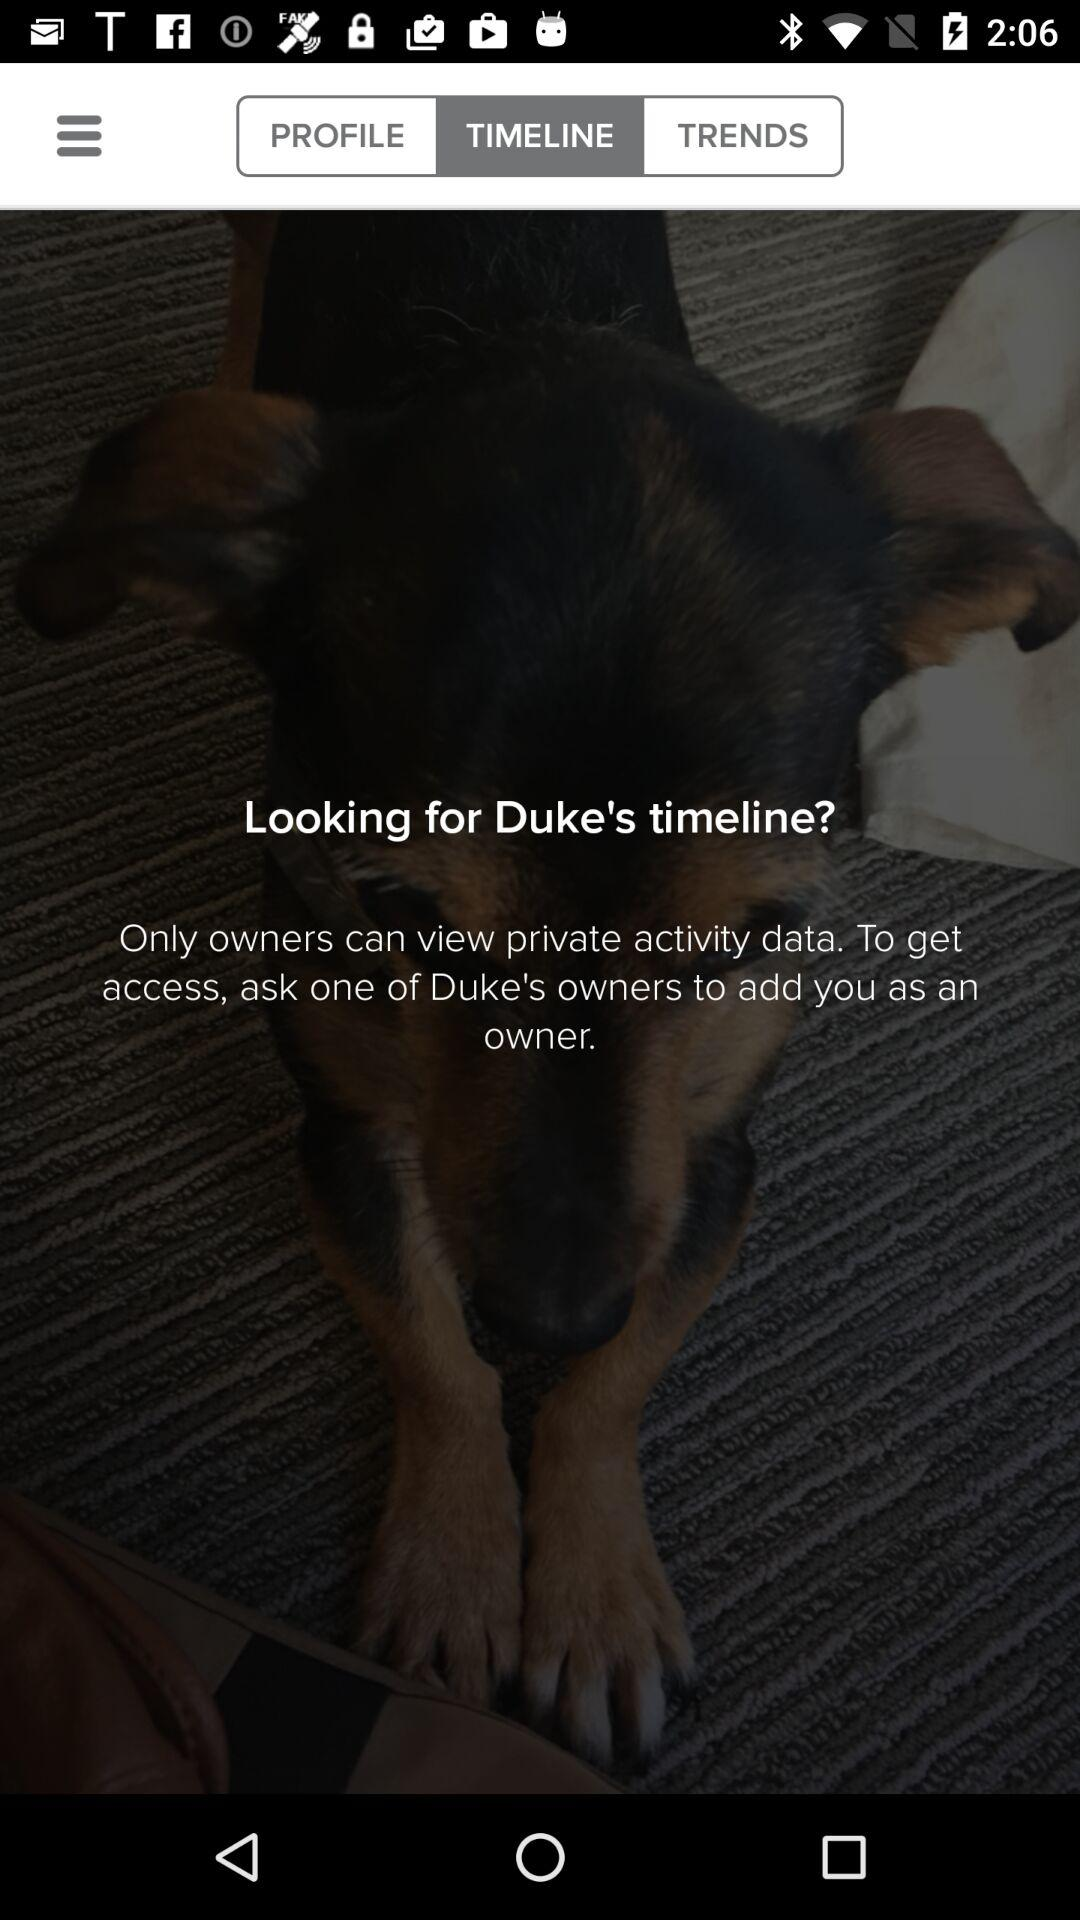Which tab has been selected? The tab that has been selected is "TIMELINE". 